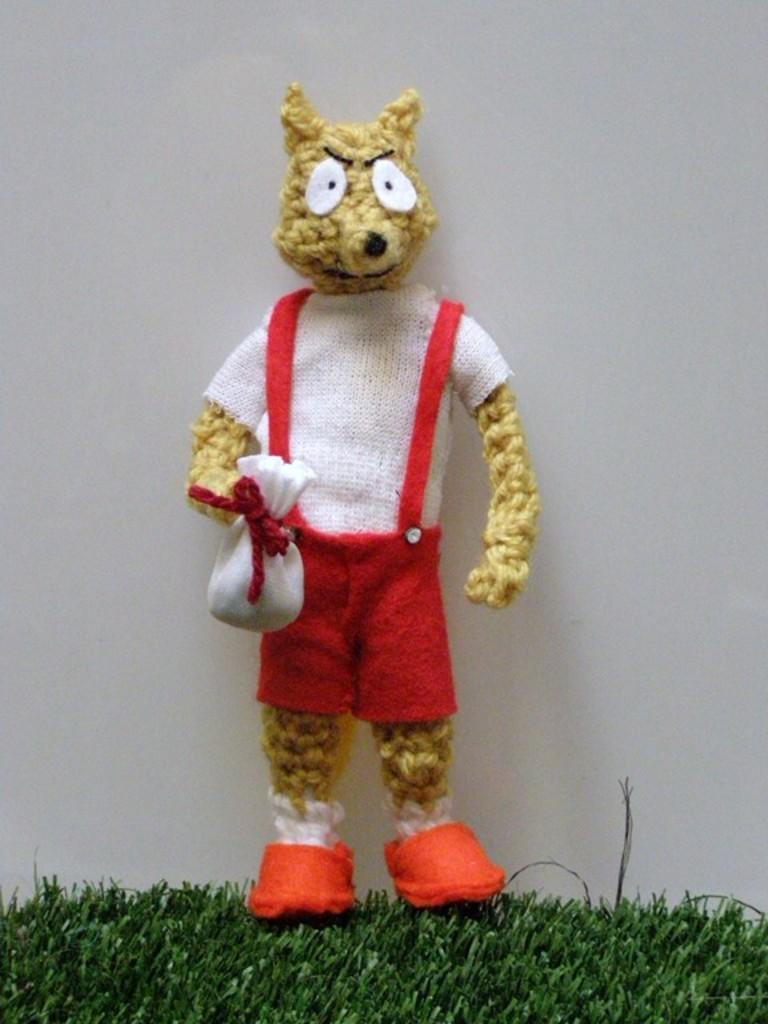Could you give a brief overview of what you see in this image? In this picture we can see a toy on the grass path and behind the toy there is a white background. 